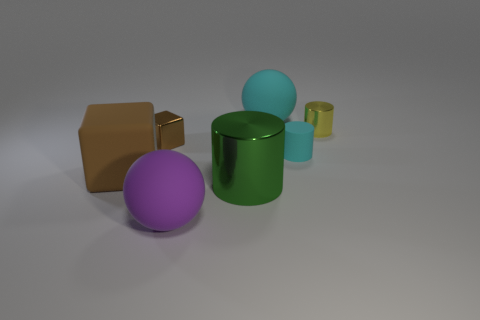Is the number of big metal things that are behind the yellow cylinder less than the number of large brown blocks behind the small brown block?
Offer a very short reply. No. What is the material of the green cylinder left of the big matte sphere that is on the right side of the large sphere on the left side of the large metallic thing?
Your answer should be very brief. Metal. There is a matte thing that is both on the right side of the tiny brown metallic cube and in front of the cyan matte cylinder; how big is it?
Offer a very short reply. Large. What number of blocks are either big purple rubber objects or green matte objects?
Make the answer very short. 0. The rubber cube that is the same size as the cyan matte ball is what color?
Your answer should be very brief. Brown. What is the color of the large thing that is the same shape as the small matte thing?
Provide a short and direct response. Green. How many things are either balls or cylinders behind the large green thing?
Give a very brief answer. 4. Are there fewer yellow objects behind the tiny matte object than cylinders?
Your response must be concise. Yes. How big is the rubber cylinder on the right side of the tiny metal thing in front of the tiny yellow metallic cylinder that is on the right side of the green metal object?
Your response must be concise. Small. There is a cylinder that is in front of the shiny cube and right of the large shiny cylinder; what color is it?
Ensure brevity in your answer.  Cyan. 